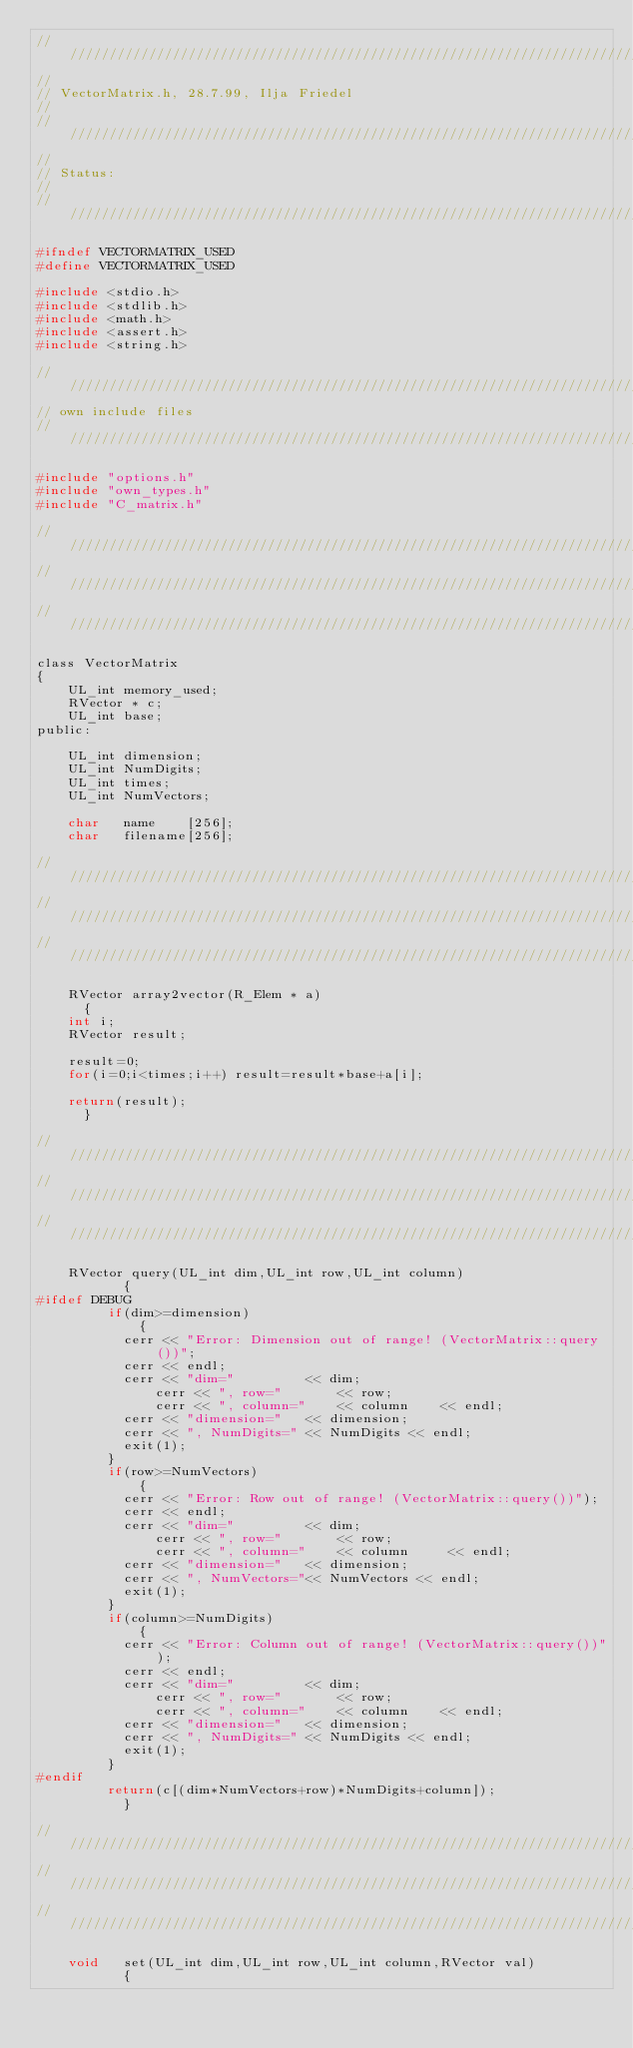Convert code to text. <code><loc_0><loc_0><loc_500><loc_500><_C_>//////////////////////////////////////////////////////////////////////////////
//
// VectorMatrix.h, 28.7.99, Ilja Friedel
//                                                                        
//////////////////////////////////////////////////////////////////////////////
//                                                                        
// Status: 
//
//////////////////////////////////////////////////////////////////////////////

#ifndef VECTORMATRIX_USED
#define VECTORMATRIX_USED

#include <stdio.h>
#include <stdlib.h>
#include <math.h>
#include <assert.h>
#include <string.h>

//////////////////////////////////////////////////////////////////////////////
// own include files 
//////////////////////////////////////////////////////////////////////////////

#include "options.h"
#include "own_types.h"
#include "C_matrix.h"

//////////////////////////////////////////////////////////////////////////////
//////////////////////////////////////////////////////////////////////////////
//////////////////////////////////////////////////////////////////////////////

class VectorMatrix
{
    UL_int memory_used; 
    RVector * c;
    UL_int base;
public:

    UL_int dimension;  
    UL_int NumDigits; 
    UL_int times;
    UL_int NumVectors;

    char   name    [256];
    char   filename[256];

//////////////////////////////////////////////////////////////////////////////
//////////////////////////////////////////////////////////////////////////////
//////////////////////////////////////////////////////////////////////////////

    RVector array2vector(R_Elem * a)
      {
	int i;
	RVector result;
	
	result=0;
	for(i=0;i<times;i++) result=result*base+a[i];
	
	return(result);
      }

//////////////////////////////////////////////////////////////////////////////
//////////////////////////////////////////////////////////////////////////////
//////////////////////////////////////////////////////////////////////////////

    RVector query(UL_int dim,UL_int row,UL_int column)
           {
#ifdef DEBUG
	     if(dim>=dimension)
             {
	       cerr << "Error: Dimension out of range! (VectorMatrix::query())";
	       cerr << endl;
	       cerr << "dim="         << dim;
               cerr << ", row="       << row;
               cerr << ", column="    << column    << endl;
	       cerr << "dimension="   << dimension;
	       cerr << ", NumDigits=" << NumDigits << endl;
	       exit(1);
	     }
	     if(row>=NumVectors)
             {
	       cerr << "Error: Row out of range! (VectorMatrix::query())");
	       cerr << endl;
	       cerr << "dim="         << dim;
               cerr << ", row="       << row;
               cerr << ", column="    << column     << endl;
	       cerr << "dimension="   << dimension;
	       cerr << ", NumVectors="<< NumVectors << endl;
	       exit(1);
	     }
	     if(column>=NumDigits)
             {
	       cerr << "Error: Column out of range! (VectorMatrix::query())");
	       cerr << endl;
	       cerr << "dim="         << dim;
               cerr << ", row="       << row;
               cerr << ", column="    << column    << endl;
	       cerr << "dimension="   << dimension;
	       cerr << ", NumDigits=" << NumDigits << endl;
	       exit(1);
	     }
#endif 
	     return(c[(dim*NumVectors+row)*NumDigits+column]);
           }  

//////////////////////////////////////////////////////////////////////////////
//////////////////////////////////////////////////////////////////////////////
//////////////////////////////////////////////////////////////////////////////

    void   set(UL_int dim,UL_int row,UL_int column,RVector val)
           {</code> 